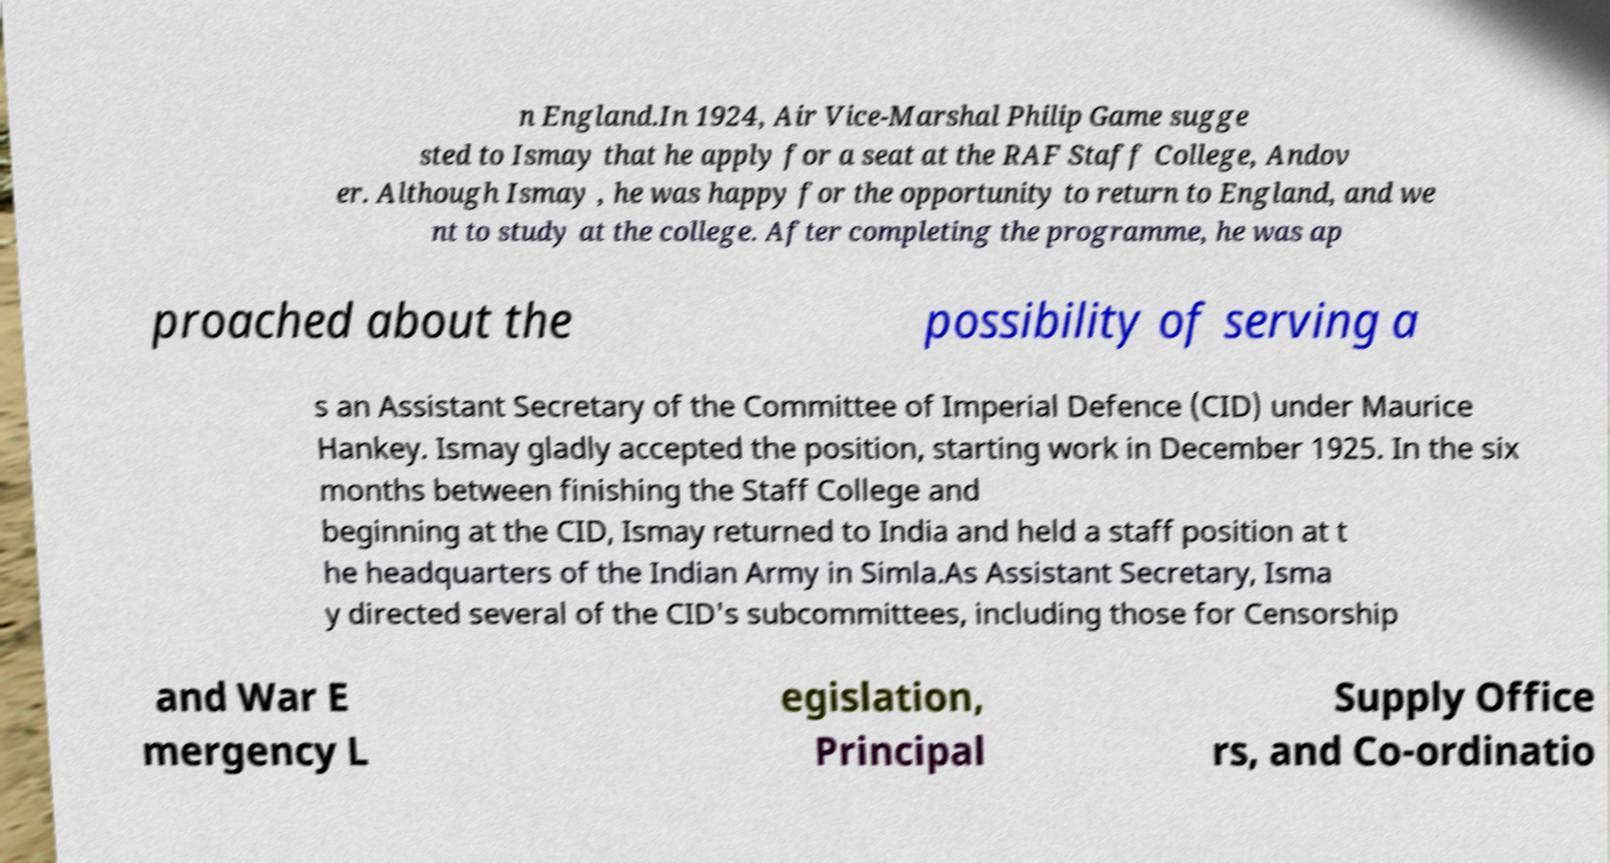Please read and relay the text visible in this image. What does it say? n England.In 1924, Air Vice-Marshal Philip Game sugge sted to Ismay that he apply for a seat at the RAF Staff College, Andov er. Although Ismay , he was happy for the opportunity to return to England, and we nt to study at the college. After completing the programme, he was ap proached about the possibility of serving a s an Assistant Secretary of the Committee of Imperial Defence (CID) under Maurice Hankey. Ismay gladly accepted the position, starting work in December 1925. In the six months between finishing the Staff College and beginning at the CID, Ismay returned to India and held a staff position at t he headquarters of the Indian Army in Simla.As Assistant Secretary, Isma y directed several of the CID's subcommittees, including those for Censorship and War E mergency L egislation, Principal Supply Office rs, and Co-ordinatio 